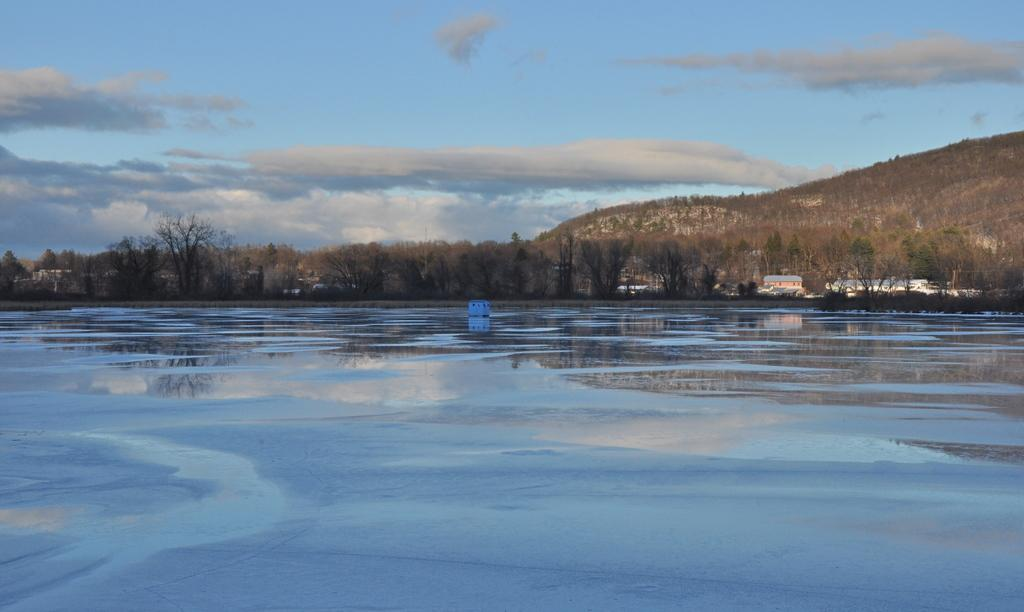What is the natural phenomenon occurring on the river in the image? Ice is formed on the river in the image. What type of structures can be seen in the image? There are buildings in the image. What type of vegetation is present in the image? There are trees in the image. What geographical feature is visible in the image? There is a hill in the image. What is visible in the background of the image? The sky is visible in the background of the image. Can you hear the plastic rustling in the image? There is no plastic present in the image, so it cannot be heard rustling. What book is the person reading in the image? There is no person reading a book in the image. 